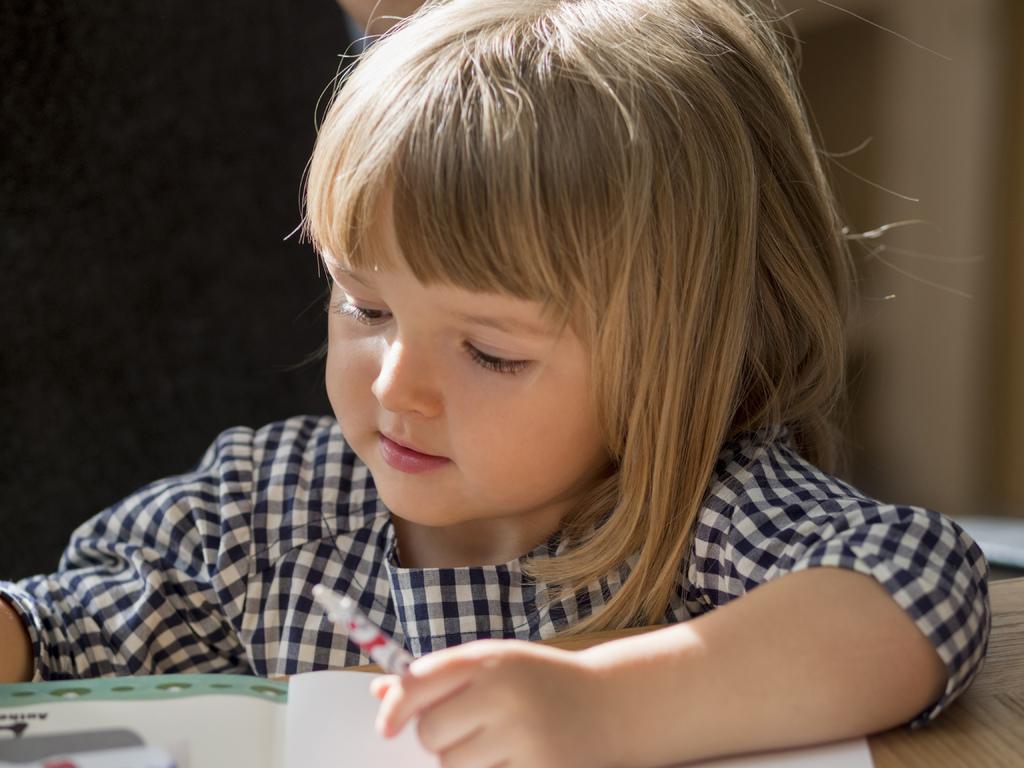In one or two sentences, can you explain what this image depicts? This is a zoomed in picture. In the center there is a kid holding a pen and seems to be sitting. In the foreground we can see the book on the top of the wooden table. In the background there are some objects. 